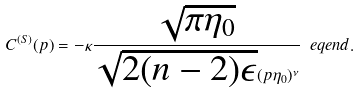<formula> <loc_0><loc_0><loc_500><loc_500>C ^ { ( S ) } ( p ) = - \kappa \frac { \sqrt { \pi \eta _ { 0 } } } { \sqrt { 2 ( n - 2 ) \epsilon } ( p \eta _ { 0 } ) ^ { \nu } } \ e q e n d { . }</formula> 